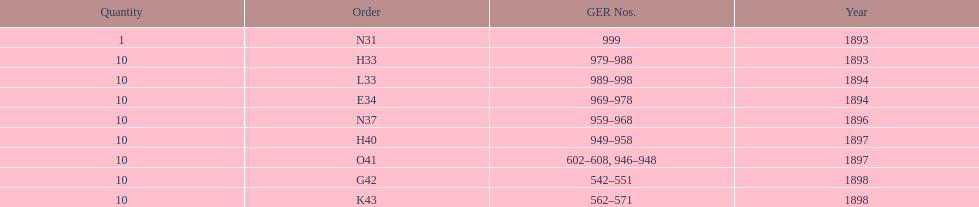Which order was the next order after l33? E34. 